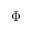<formula> <loc_0><loc_0><loc_500><loc_500>\Phi</formula> 